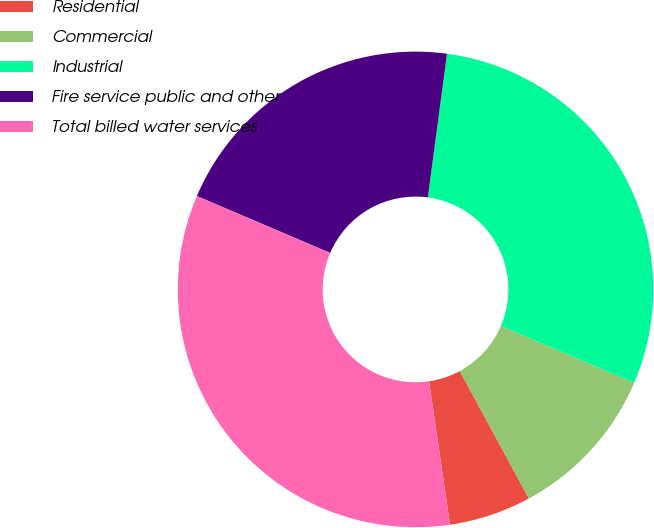<chart> <loc_0><loc_0><loc_500><loc_500><pie_chart><fcel>Residential<fcel>Commercial<fcel>Industrial<fcel>Fire service public and other<fcel>Total billed water services<nl><fcel>5.59%<fcel>10.67%<fcel>29.31%<fcel>20.69%<fcel>33.74%<nl></chart> 